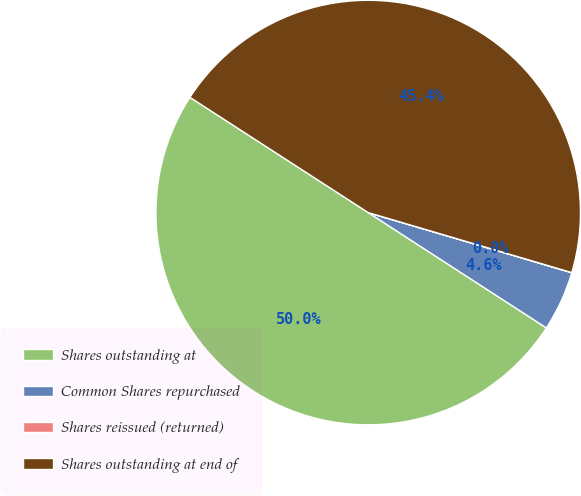Convert chart to OTSL. <chart><loc_0><loc_0><loc_500><loc_500><pie_chart><fcel>Shares outstanding at<fcel>Common Shares repurchased<fcel>Shares reissued (returned)<fcel>Shares outstanding at end of<nl><fcel>49.99%<fcel>4.57%<fcel>0.01%<fcel>45.43%<nl></chart> 